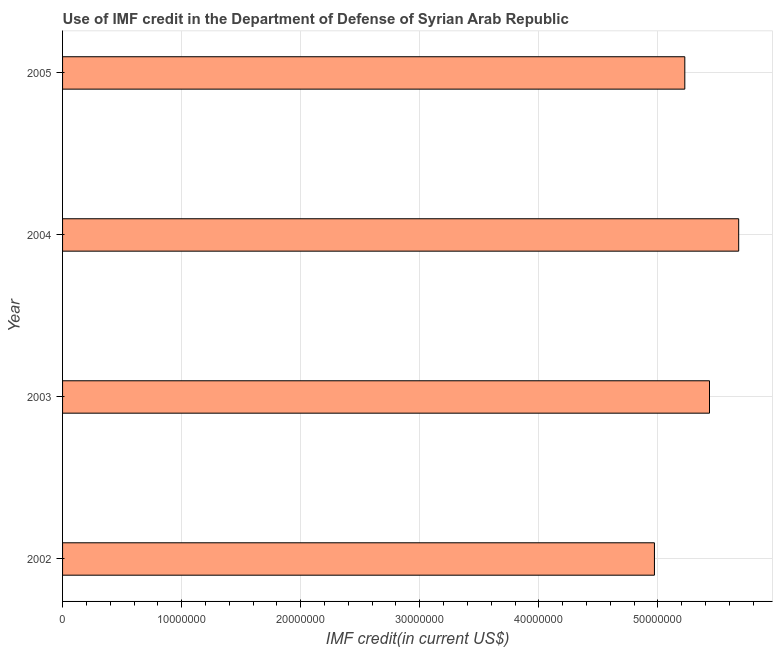Does the graph contain any zero values?
Ensure brevity in your answer.  No. Does the graph contain grids?
Ensure brevity in your answer.  Yes. What is the title of the graph?
Ensure brevity in your answer.  Use of IMF credit in the Department of Defense of Syrian Arab Republic. What is the label or title of the X-axis?
Keep it short and to the point. IMF credit(in current US$). What is the use of imf credit in dod in 2003?
Ensure brevity in your answer.  5.43e+07. Across all years, what is the maximum use of imf credit in dod?
Ensure brevity in your answer.  5.68e+07. Across all years, what is the minimum use of imf credit in dod?
Offer a very short reply. 4.97e+07. In which year was the use of imf credit in dod maximum?
Your answer should be very brief. 2004. In which year was the use of imf credit in dod minimum?
Your answer should be very brief. 2002. What is the sum of the use of imf credit in dod?
Offer a terse response. 2.13e+08. What is the difference between the use of imf credit in dod in 2002 and 2004?
Offer a terse response. -7.08e+06. What is the average use of imf credit in dod per year?
Your response must be concise. 5.33e+07. What is the median use of imf credit in dod?
Provide a succinct answer. 5.33e+07. What is the ratio of the use of imf credit in dod in 2002 to that in 2004?
Provide a succinct answer. 0.88. Is the difference between the use of imf credit in dod in 2002 and 2004 greater than the difference between any two years?
Keep it short and to the point. Yes. What is the difference between the highest and the second highest use of imf credit in dod?
Offer a very short reply. 2.45e+06. What is the difference between the highest and the lowest use of imf credit in dod?
Offer a very short reply. 7.08e+06. In how many years, is the use of imf credit in dod greater than the average use of imf credit in dod taken over all years?
Your answer should be very brief. 2. How many bars are there?
Ensure brevity in your answer.  4. Are all the bars in the graph horizontal?
Offer a very short reply. Yes. What is the IMF credit(in current US$) in 2002?
Ensure brevity in your answer.  4.97e+07. What is the IMF credit(in current US$) in 2003?
Make the answer very short. 5.43e+07. What is the IMF credit(in current US$) of 2004?
Provide a short and direct response. 5.68e+07. What is the IMF credit(in current US$) of 2005?
Your answer should be compact. 5.23e+07. What is the difference between the IMF credit(in current US$) in 2002 and 2003?
Offer a very short reply. -4.62e+06. What is the difference between the IMF credit(in current US$) in 2002 and 2004?
Give a very brief answer. -7.08e+06. What is the difference between the IMF credit(in current US$) in 2002 and 2005?
Provide a short and direct response. -2.55e+06. What is the difference between the IMF credit(in current US$) in 2003 and 2004?
Your answer should be very brief. -2.45e+06. What is the difference between the IMF credit(in current US$) in 2003 and 2005?
Your response must be concise. 2.07e+06. What is the difference between the IMF credit(in current US$) in 2004 and 2005?
Keep it short and to the point. 4.52e+06. What is the ratio of the IMF credit(in current US$) in 2002 to that in 2003?
Provide a succinct answer. 0.92. What is the ratio of the IMF credit(in current US$) in 2002 to that in 2004?
Provide a short and direct response. 0.88. What is the ratio of the IMF credit(in current US$) in 2002 to that in 2005?
Your answer should be compact. 0.95. What is the ratio of the IMF credit(in current US$) in 2003 to that in 2004?
Keep it short and to the point. 0.96. What is the ratio of the IMF credit(in current US$) in 2003 to that in 2005?
Give a very brief answer. 1.04. What is the ratio of the IMF credit(in current US$) in 2004 to that in 2005?
Provide a short and direct response. 1.09. 